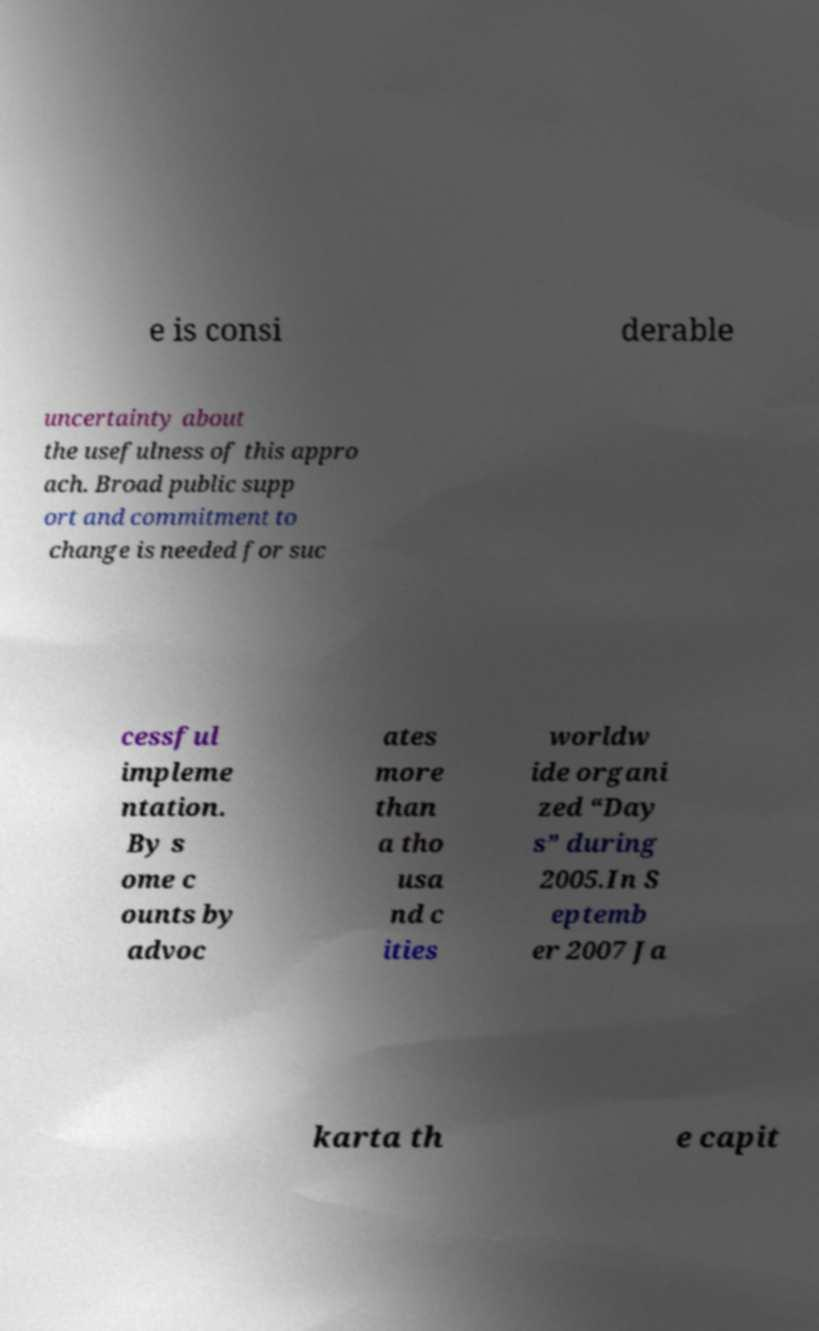For documentation purposes, I need the text within this image transcribed. Could you provide that? e is consi derable uncertainty about the usefulness of this appro ach. Broad public supp ort and commitment to change is needed for suc cessful impleme ntation. By s ome c ounts by advoc ates more than a tho usa nd c ities worldw ide organi zed “Day s” during 2005.In S eptemb er 2007 Ja karta th e capit 